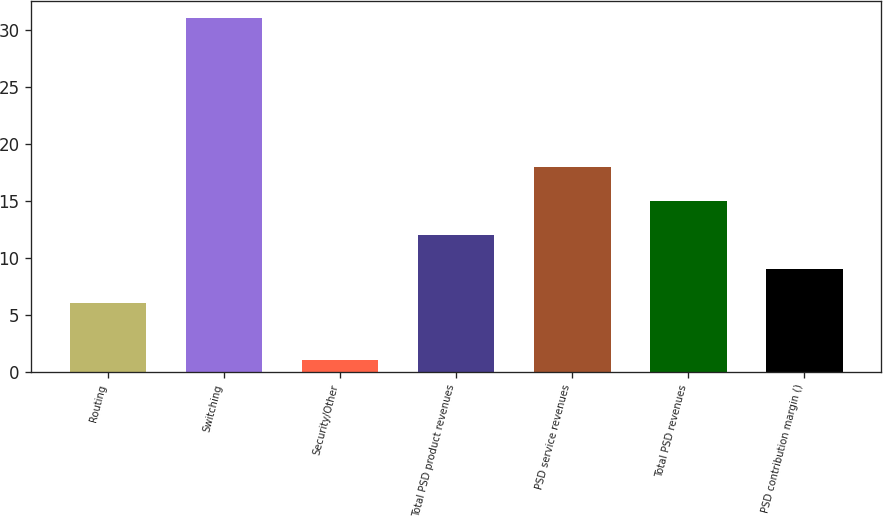Convert chart. <chart><loc_0><loc_0><loc_500><loc_500><bar_chart><fcel>Routing<fcel>Switching<fcel>Security/Other<fcel>Total PSD product revenues<fcel>PSD service revenues<fcel>Total PSD revenues<fcel>PSD contribution margin ()<nl><fcel>6<fcel>31<fcel>1<fcel>12<fcel>18<fcel>15<fcel>9<nl></chart> 